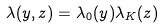Convert formula to latex. <formula><loc_0><loc_0><loc_500><loc_500>\lambda ( y , z ) = \lambda _ { 0 } ( y ) \lambda _ { K } ( z )</formula> 